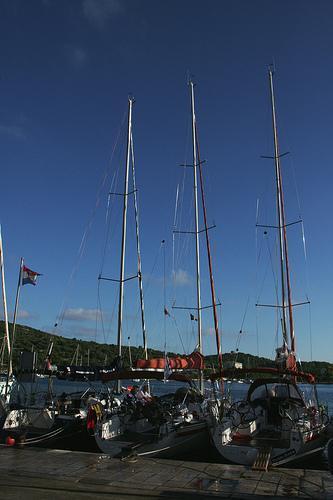How many boats are pictures?
Give a very brief answer. 3. 